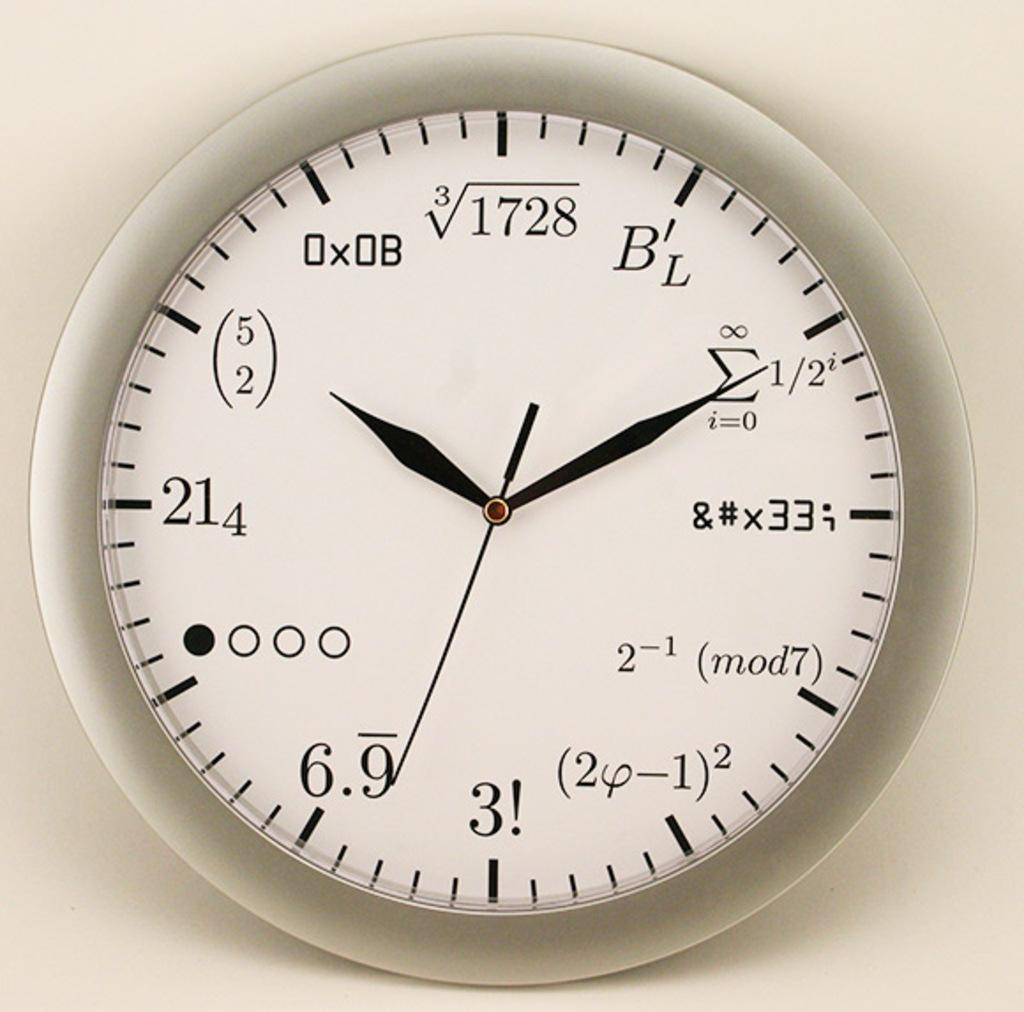<image>
Share a concise interpretation of the image provided. The clock face features mathematical equations rather than the standard numbers 1 through 12. 